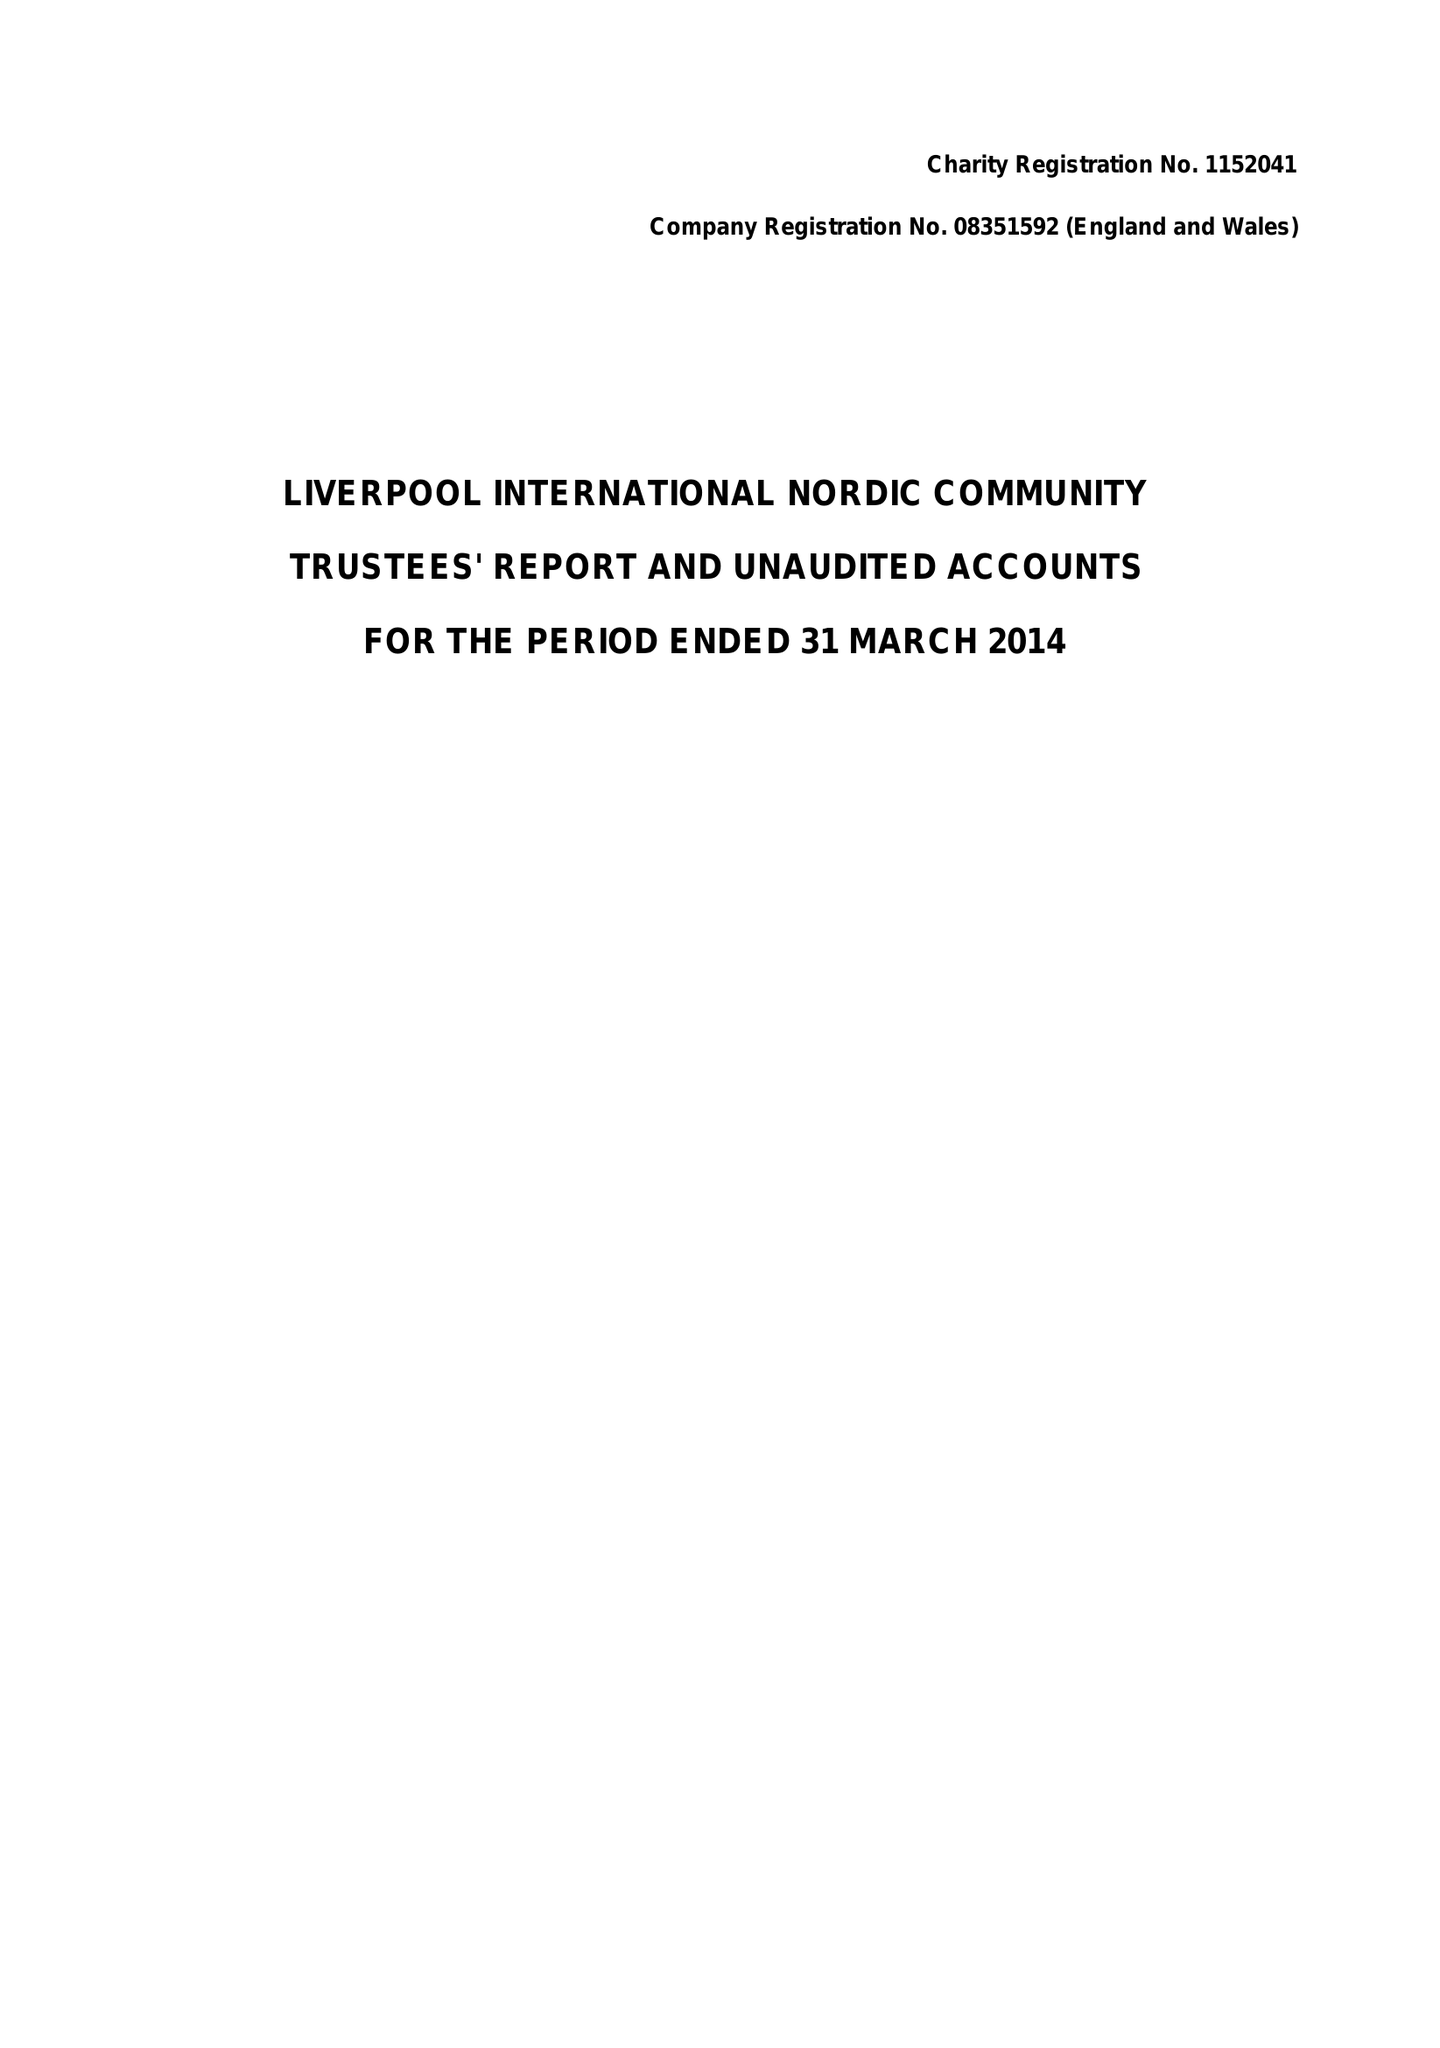What is the value for the address__postcode?
Answer the question using a single word or phrase. L1 8HG 